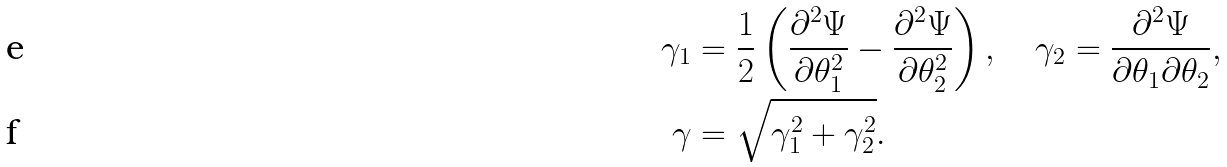<formula> <loc_0><loc_0><loc_500><loc_500>\gamma _ { 1 } & = \frac { 1 } { 2 } \left ( \frac { \partial ^ { 2 } \Psi } { \partial \theta _ { 1 } ^ { 2 } } - \frac { \partial ^ { 2 } \Psi } { \partial \theta _ { 2 } ^ { 2 } } \right ) , \quad \gamma _ { 2 } = \frac { \partial ^ { 2 } \Psi } { \partial \theta _ { 1 } \partial \theta _ { 2 } } , \\ \gamma & = \sqrt { \gamma _ { 1 } ^ { 2 } + \gamma _ { 2 } ^ { 2 } } .</formula> 